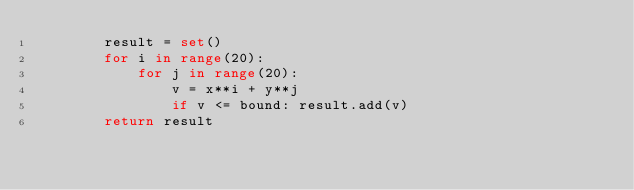Convert code to text. <code><loc_0><loc_0><loc_500><loc_500><_Python_>        result = set()
        for i in range(20):
            for j in range(20):
                v = x**i + y**j
                if v <= bound: result.add(v)
        return result</code> 